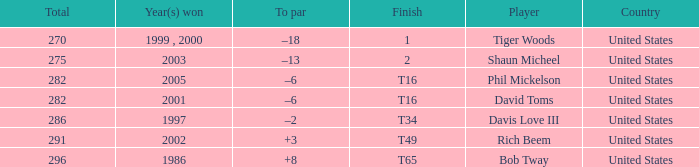What is Davis Love III's total? 286.0. 